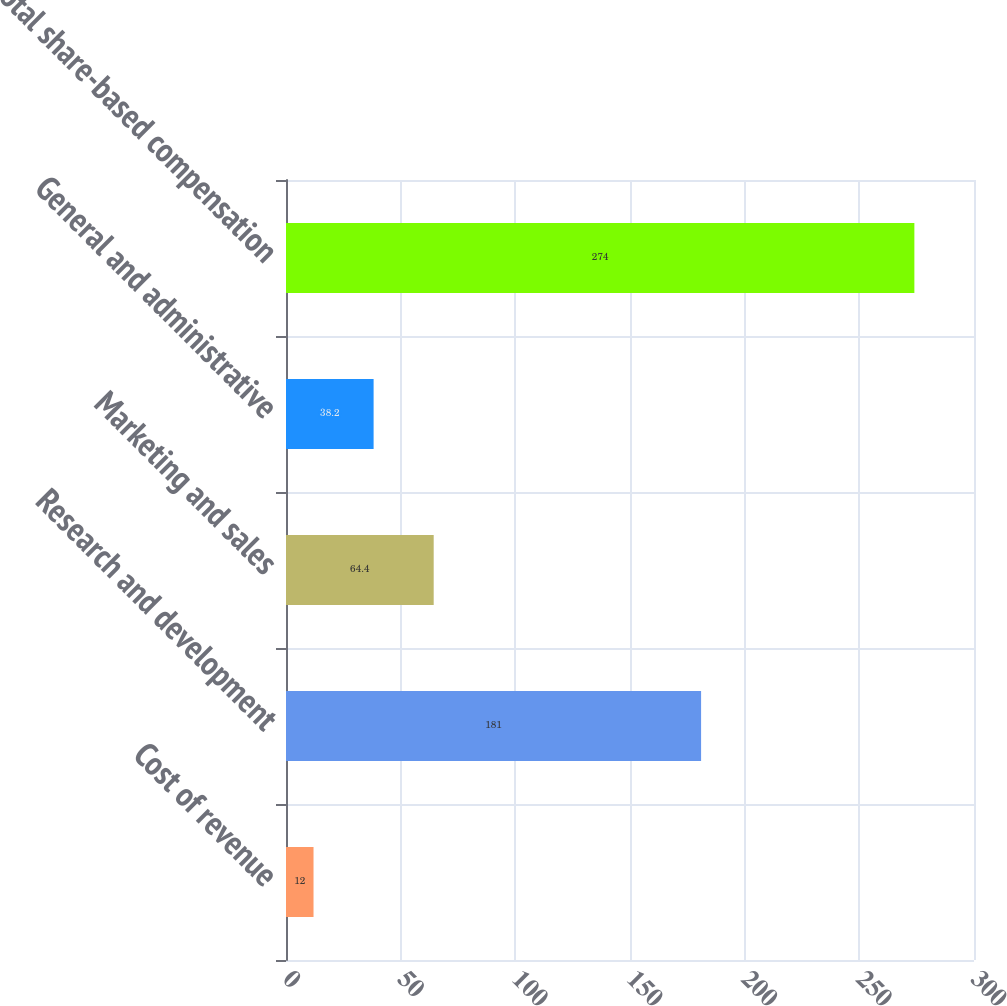Convert chart. <chart><loc_0><loc_0><loc_500><loc_500><bar_chart><fcel>Cost of revenue<fcel>Research and development<fcel>Marketing and sales<fcel>General and administrative<fcel>Total share-based compensation<nl><fcel>12<fcel>181<fcel>64.4<fcel>38.2<fcel>274<nl></chart> 